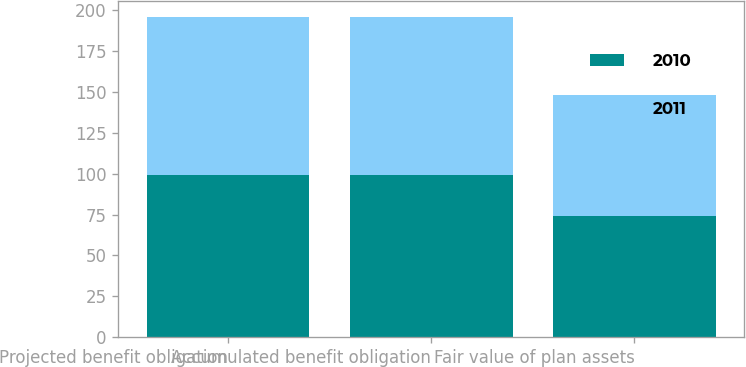<chart> <loc_0><loc_0><loc_500><loc_500><stacked_bar_chart><ecel><fcel>Projected benefit obligation<fcel>Accumulated benefit obligation<fcel>Fair value of plan assets<nl><fcel>2010<fcel>99<fcel>99<fcel>74<nl><fcel>2011<fcel>97<fcel>97<fcel>74<nl></chart> 